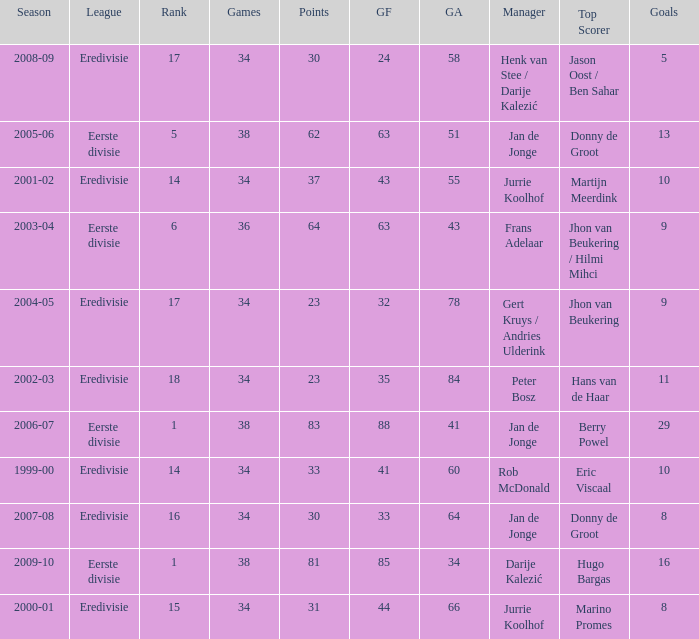Who is the manager whose rank is 16? Jan de Jonge. 